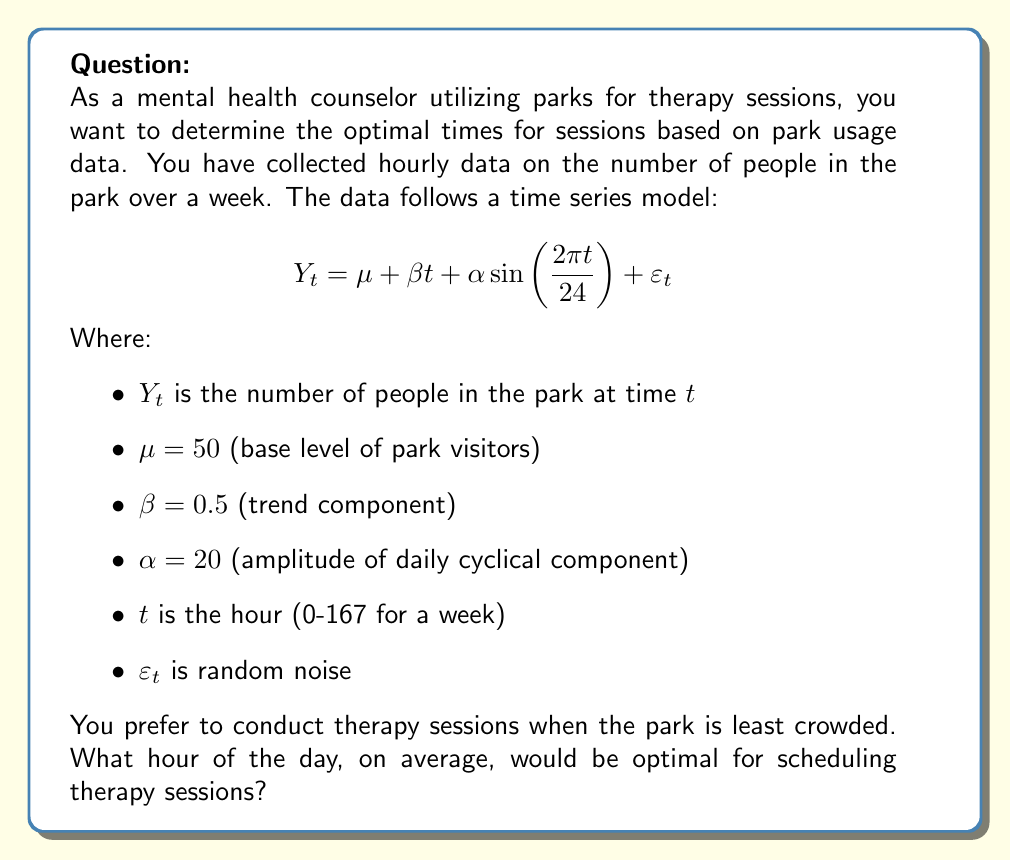Solve this math problem. To determine the optimal time for therapy sessions, we need to find the hour of the day when the park is least crowded on average. Let's approach this step-by-step:

1) First, we can ignore the random noise $\varepsilon_t$ as we're looking for the average pattern.

2) The trend component $\beta t$ increases steadily over time, but we're interested in the daily pattern, so we can ignore this for now.

3) The key component for our analysis is the cyclical term: $\alpha \sin(\frac{2\pi t}{24})$

4) This term has a period of 24 hours, matching the daily cycle. Its minimum occurs when the sine function is at its minimum (-1).

5) The sine function reaches its minimum when its argument is $\frac{3\pi}{2}$ or $\frac{7\pi}{2}$ (equivalent in this cyclical context).

6) So, we need to solve:

   $$\frac{2\pi t}{24} = \frac{3\pi}{2}$$

7) Solving for $t$:
   
   $$t = \frac{24 \cdot \frac{3\pi}{2}}{2\pi} = 18$$

8) This means the cyclical component reaches its minimum at hour 18, or 6 PM.

9) At this time, the cyclical component contributes:
   
   $$20 \sin(\frac{2\pi \cdot 18}{24}) = 20 \sin(\frac{3\pi}{2}) = -20$$

10) So, at 6 PM each day, the park will have on average:

    $$50 + 0.5t - 20$$ visitors

    The $0.5t$ term will vary depending on the day of the week, but 6 PM will consistently be the least crowded time each day.
Answer: The optimal time for scheduling therapy sessions, on average, would be at 6 PM (hour 18) each day. 